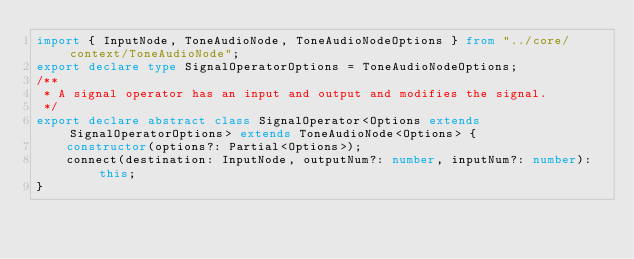Convert code to text. <code><loc_0><loc_0><loc_500><loc_500><_TypeScript_>import { InputNode, ToneAudioNode, ToneAudioNodeOptions } from "../core/context/ToneAudioNode";
export declare type SignalOperatorOptions = ToneAudioNodeOptions;
/**
 * A signal operator has an input and output and modifies the signal.
 */
export declare abstract class SignalOperator<Options extends SignalOperatorOptions> extends ToneAudioNode<Options> {
    constructor(options?: Partial<Options>);
    connect(destination: InputNode, outputNum?: number, inputNum?: number): this;
}
</code> 